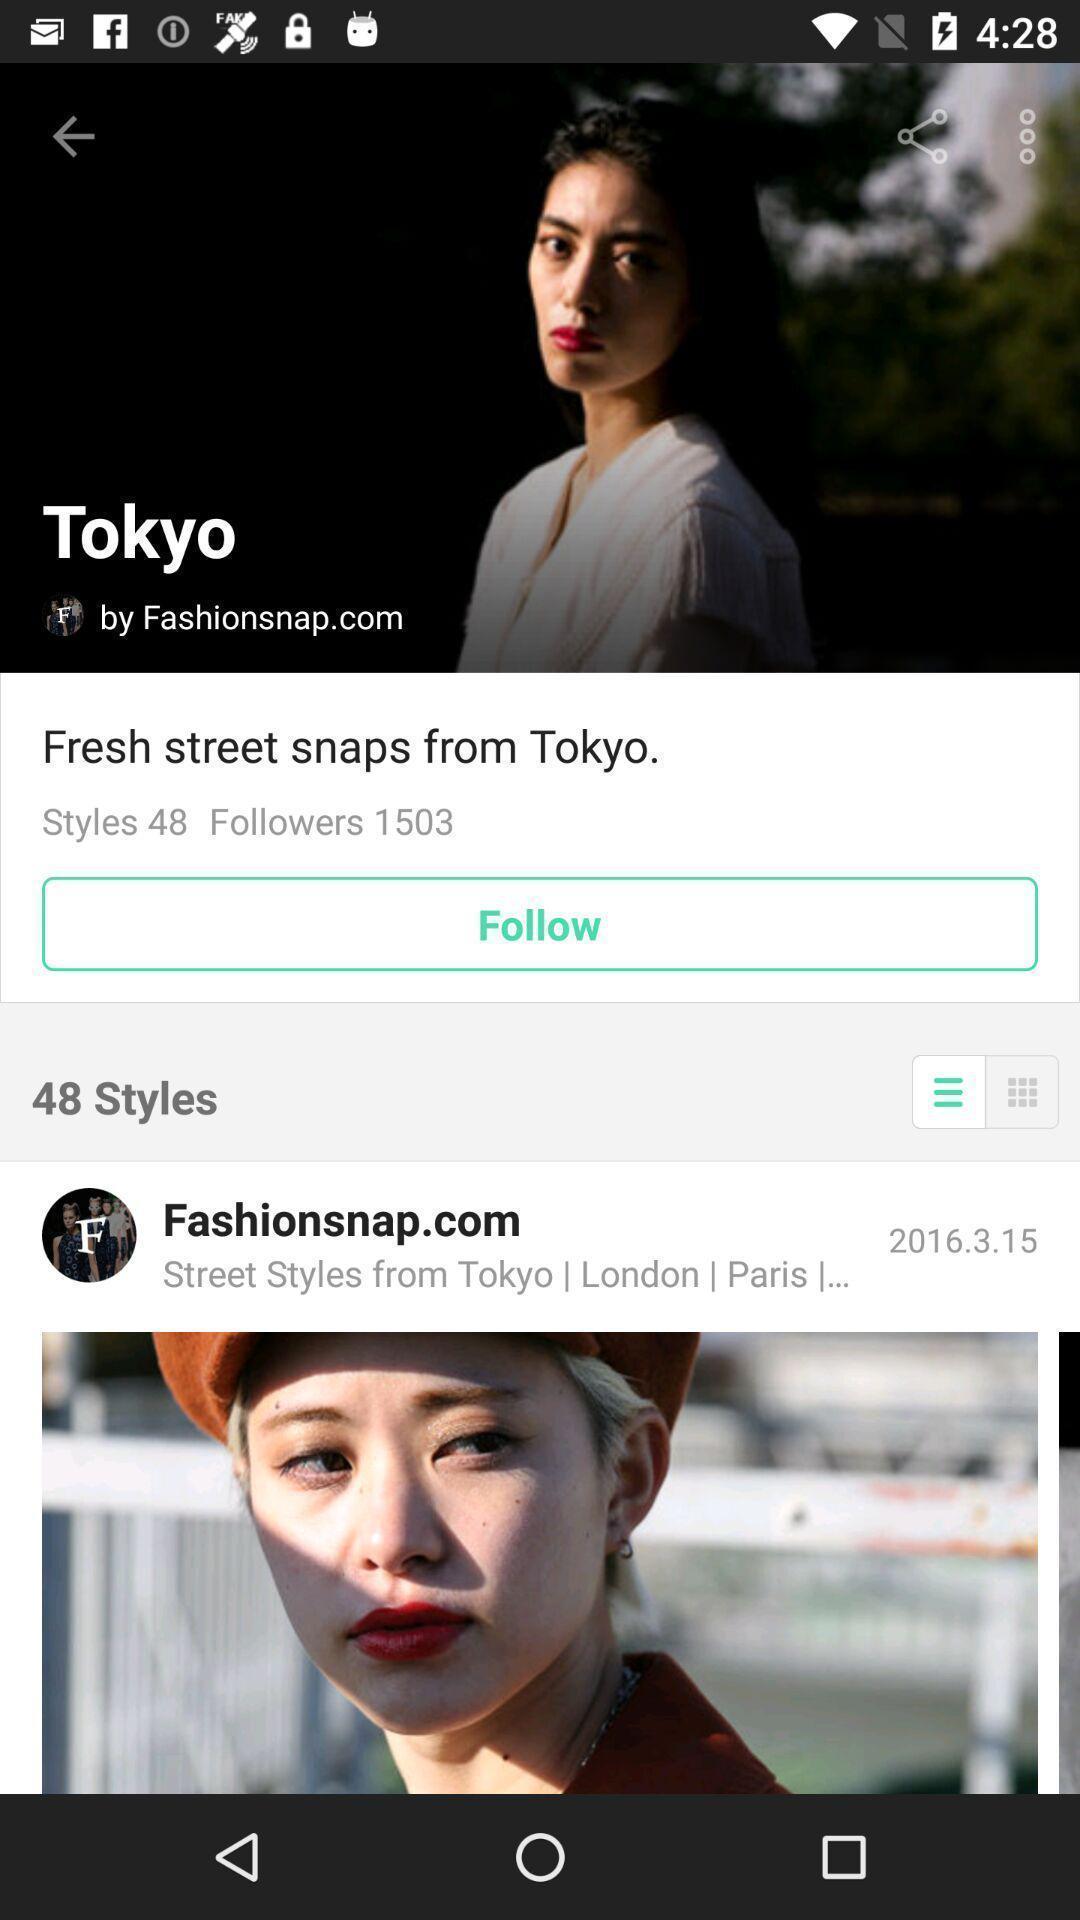What is the overall content of this screenshot? Screen display multiple fashionistas. 